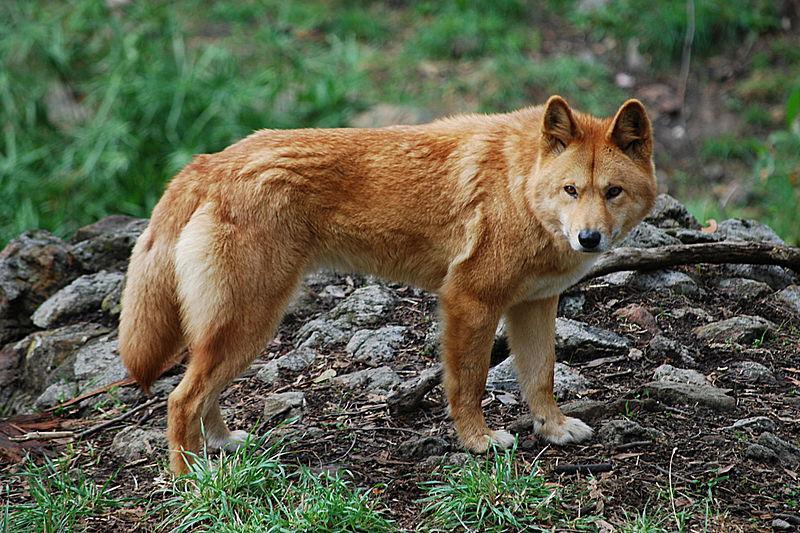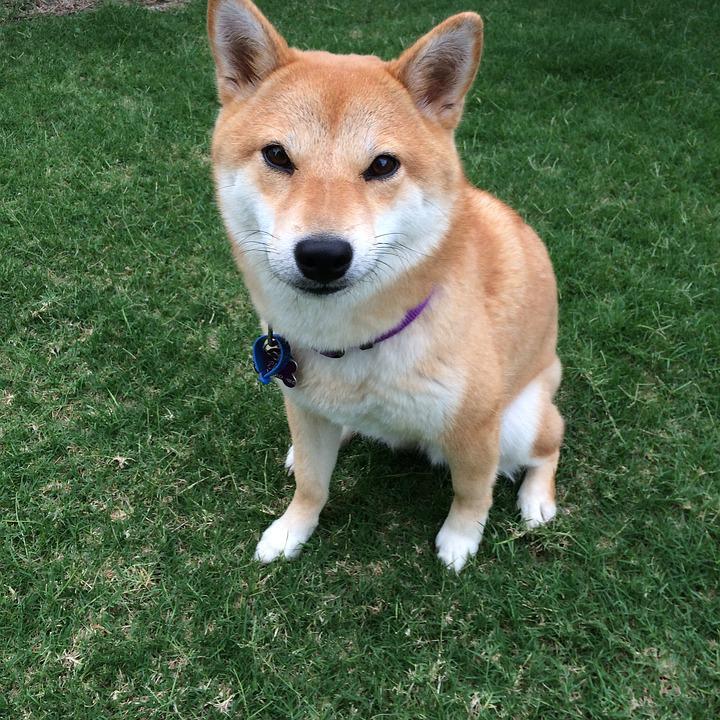The first image is the image on the left, the second image is the image on the right. For the images displayed, is the sentence "At least one dog is not wearing a collar." factually correct? Answer yes or no. Yes. 